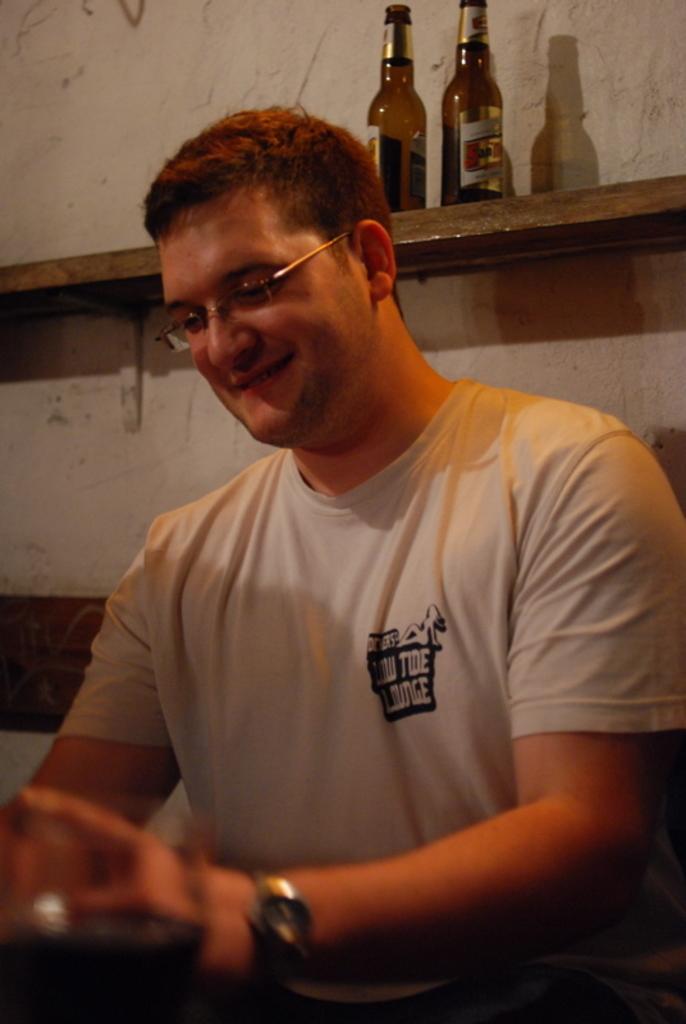In one or two sentences, can you explain what this image depicts? This image is taken indoors. In the background there is a wall and there is a shelf with two bottles on it. In the middle of the image there is a man and he is with a smiling face. 